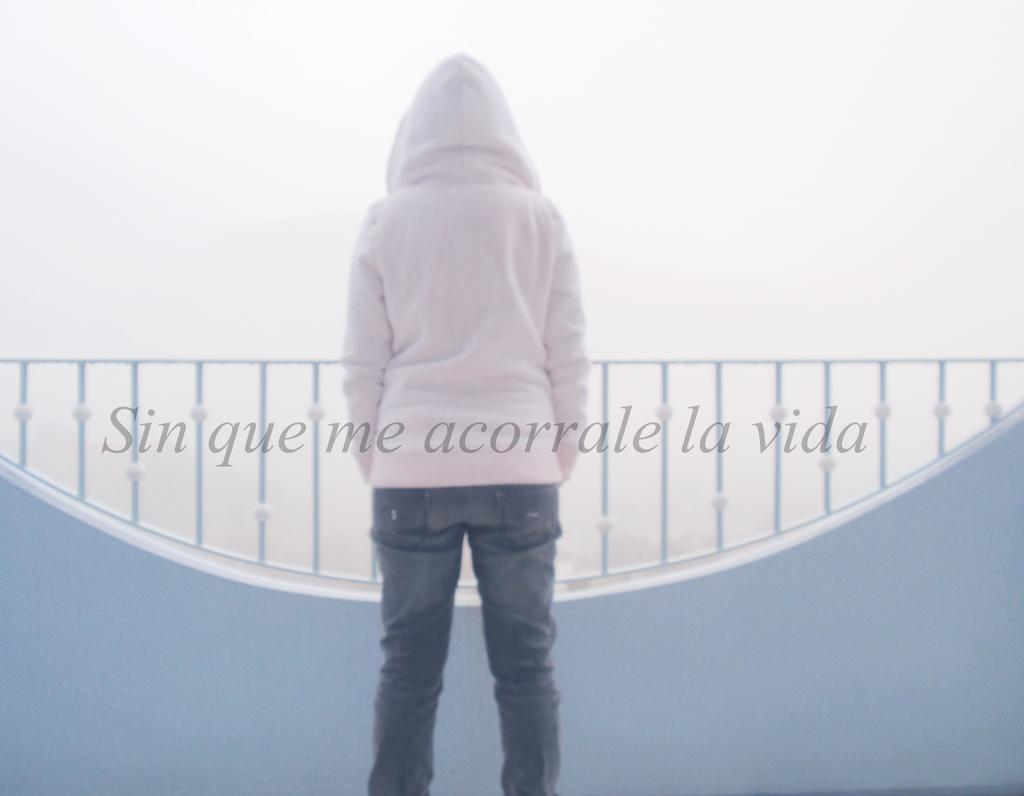What is the main subject of the image? There is a person in the image. What is the person doing in the image? The person is standing. Can you describe the person's posture or orientation in the image? The person's back is facing the viewer. What can be seen in the background of the image? There is a fence visible behind the person. Is there any text present in the image? Yes, there is text on the image. What type of cup is the person holding in the image? There is no cup present in the image; the person's back is facing the viewer, and no cup can be seen. Is the person wearing a scarf in the image? There is no mention of a scarf in the image, and the person's back is facing the viewer, so it cannot be determined if they are wearing a scarf. 